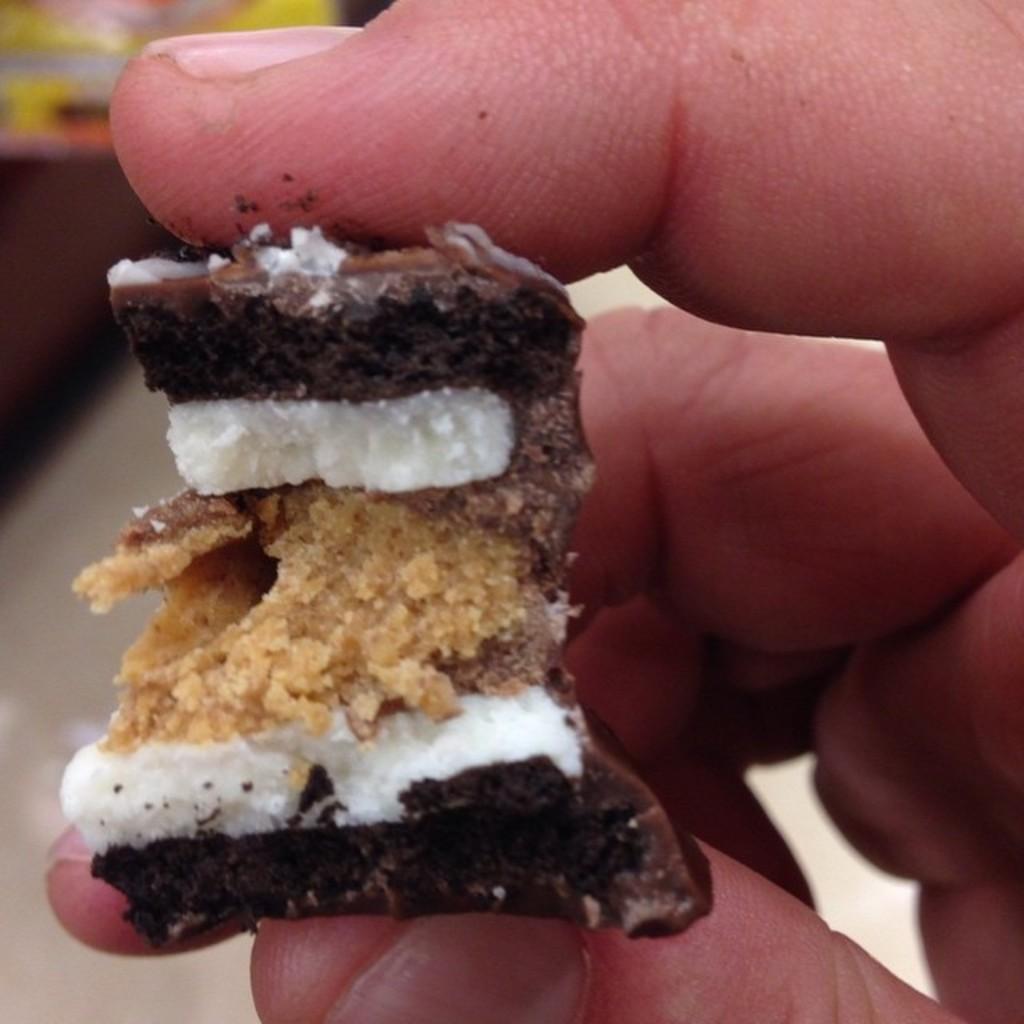How would you summarize this image in a sentence or two? In this picture we can see a person holding a food item and in the background we can see it is blurry. 